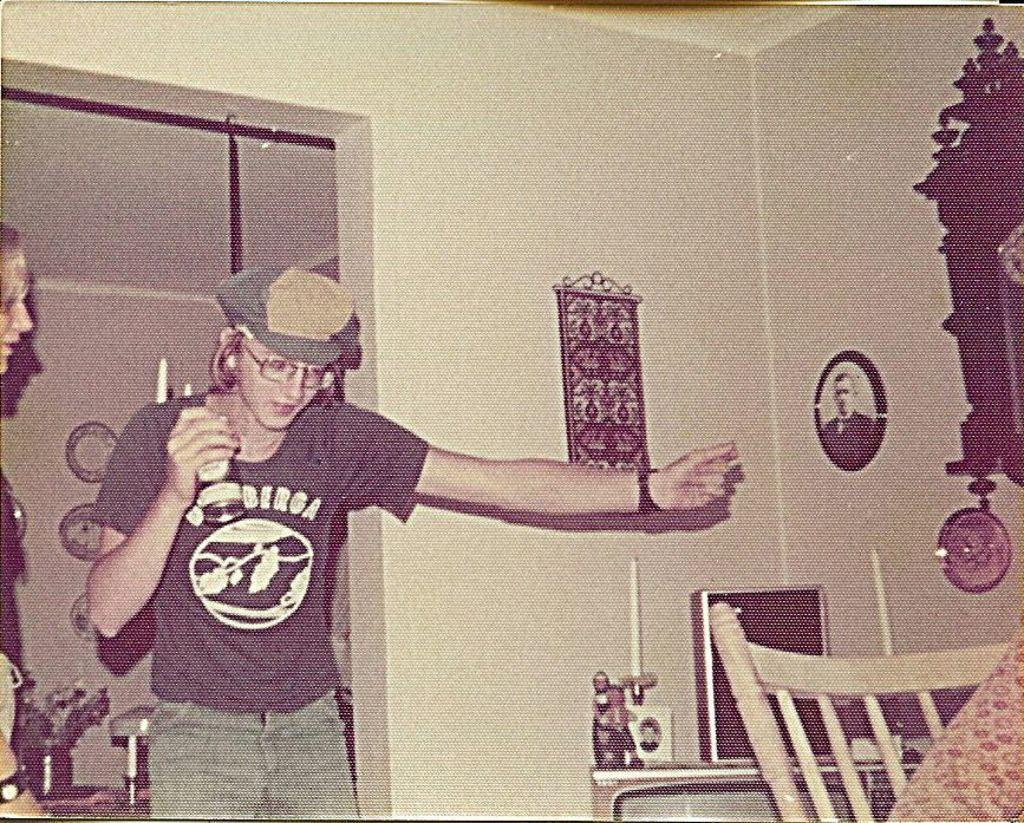What is the person on the left side of the image wearing? The person is wearing a t-shirt, trousers, spectacles, and a cap. Can you describe the person's headwear in the image? The person is wearing a cap. What is present on the right side of the image? There is a photo frame on the wall on the right side of the image. What type of shoe is the person wearing on the left side of the image? The facts do not mention any shoes being worn by the person in the image. 